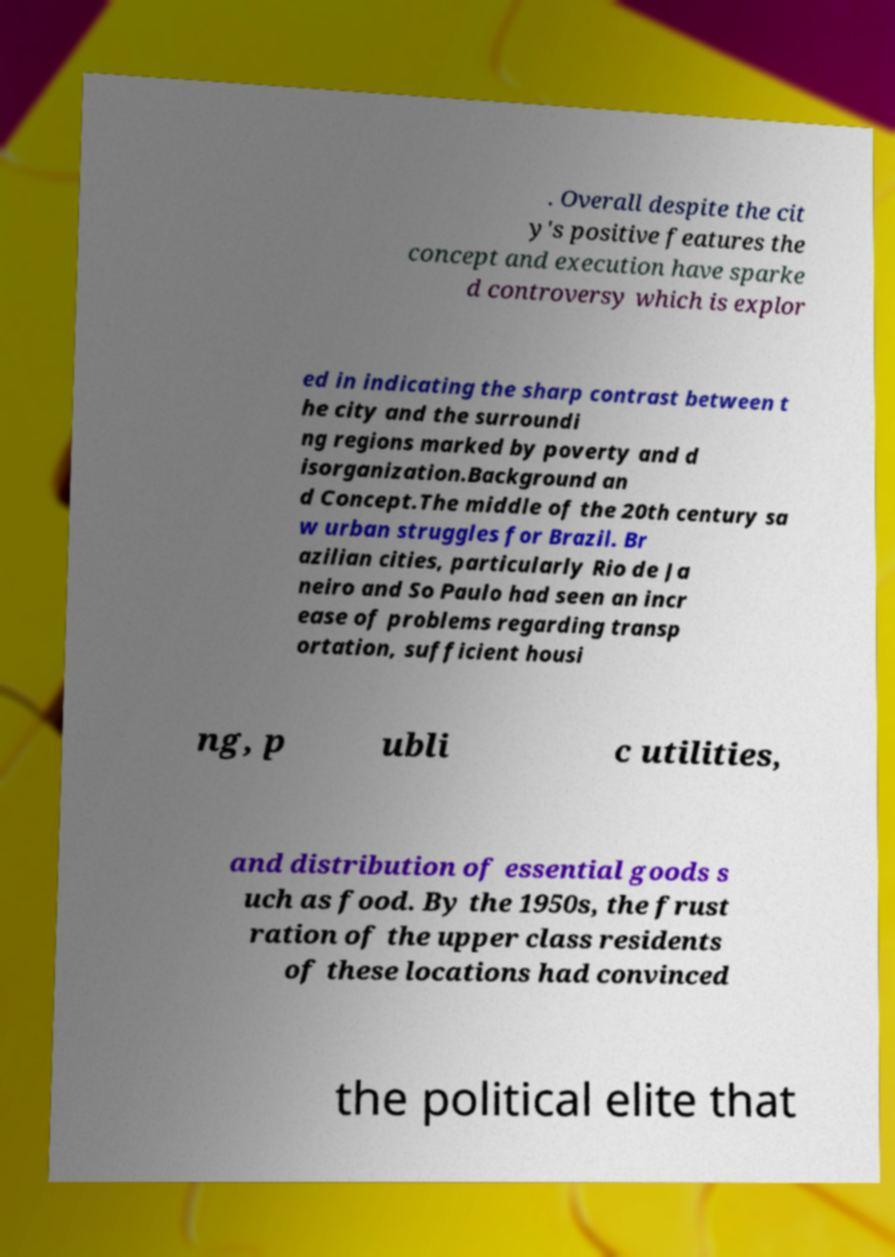There's text embedded in this image that I need extracted. Can you transcribe it verbatim? . Overall despite the cit y's positive features the concept and execution have sparke d controversy which is explor ed in indicating the sharp contrast between t he city and the surroundi ng regions marked by poverty and d isorganization.Background an d Concept.The middle of the 20th century sa w urban struggles for Brazil. Br azilian cities, particularly Rio de Ja neiro and So Paulo had seen an incr ease of problems regarding transp ortation, sufficient housi ng, p ubli c utilities, and distribution of essential goods s uch as food. By the 1950s, the frust ration of the upper class residents of these locations had convinced the political elite that 